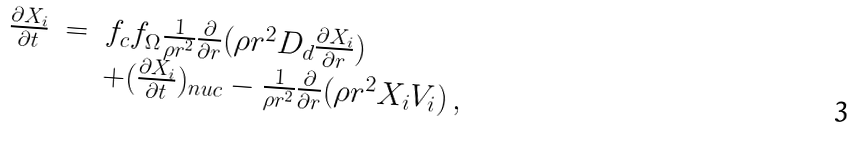Convert formula to latex. <formula><loc_0><loc_0><loc_500><loc_500>\begin{array} { l l l } \frac { \partial X _ { i } } { \partial t } & = & f _ { c } f _ { \Omega } \frac { 1 } { \rho r ^ { 2 } } \frac { \partial } { \partial r } ( \rho r ^ { 2 } D _ { d } \frac { \partial X _ { i } } { \partial r } ) \\ & & + ( \frac { \partial X _ { i } } { \partial t } ) _ { n u c } - \frac { 1 } { \rho r ^ { 2 } } \frac { \partial } { \partial r } ( \rho r ^ { 2 } X _ { i } V _ { i } ) \, , \end{array}</formula> 